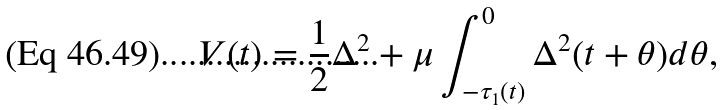Convert formula to latex. <formula><loc_0><loc_0><loc_500><loc_500>V ( t ) = \frac { 1 } { 2 } \Delta ^ { 2 } + \mu \int _ { - \tau _ { 1 } ( t ) } ^ { 0 } \Delta ^ { 2 } ( t + \theta ) d \theta ,</formula> 